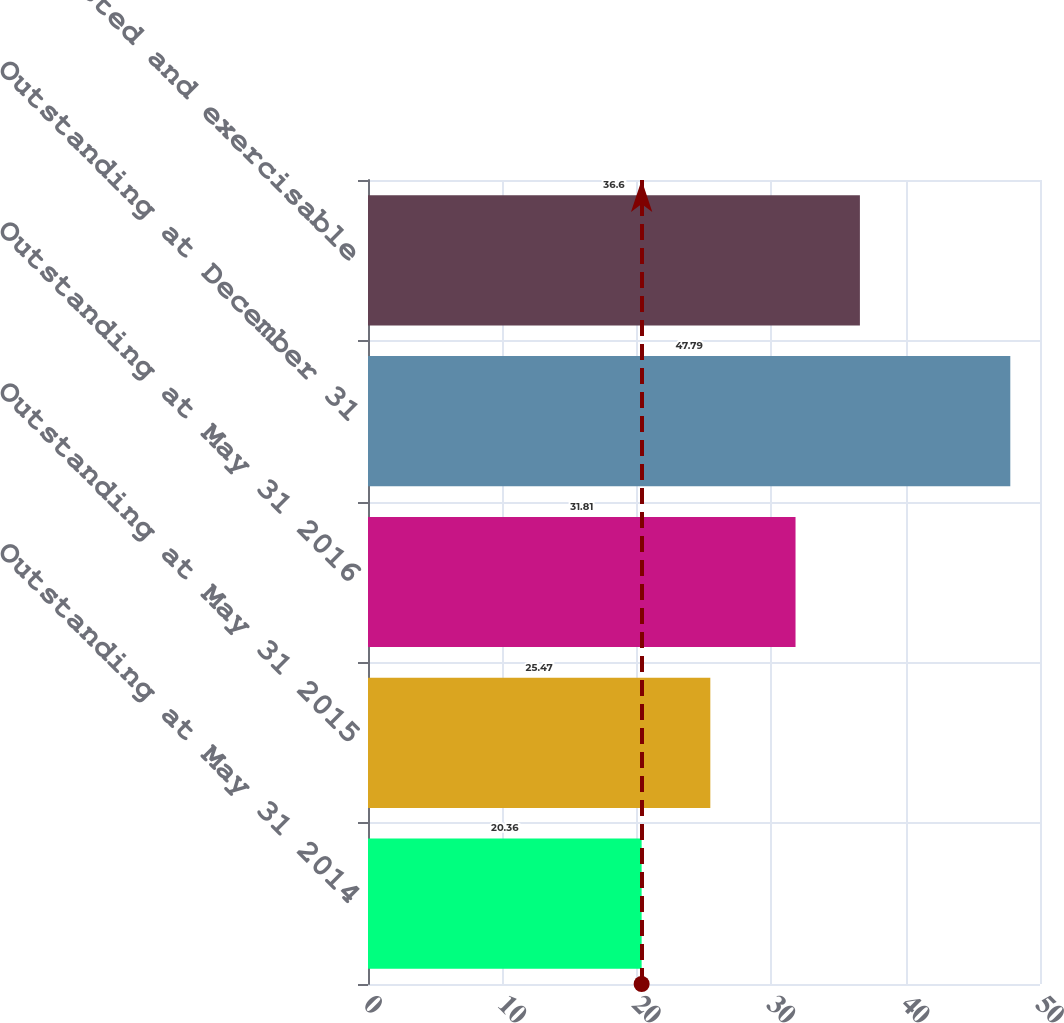<chart> <loc_0><loc_0><loc_500><loc_500><bar_chart><fcel>Outstanding at May 31 2014<fcel>Outstanding at May 31 2015<fcel>Outstanding at May 31 2016<fcel>Outstanding at December 31<fcel>Options vested and exercisable<nl><fcel>20.36<fcel>25.47<fcel>31.81<fcel>47.79<fcel>36.6<nl></chart> 